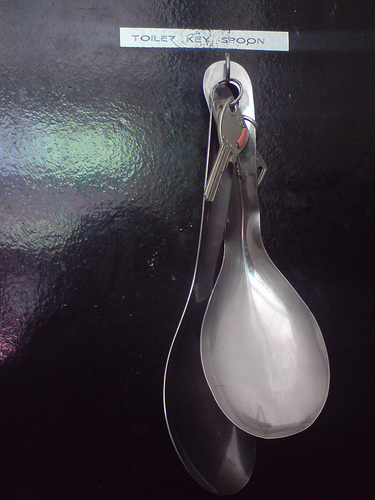<image>
Is the spoon one to the left of the spoon two? No. The spoon one is not to the left of the spoon two. From this viewpoint, they have a different horizontal relationship. 